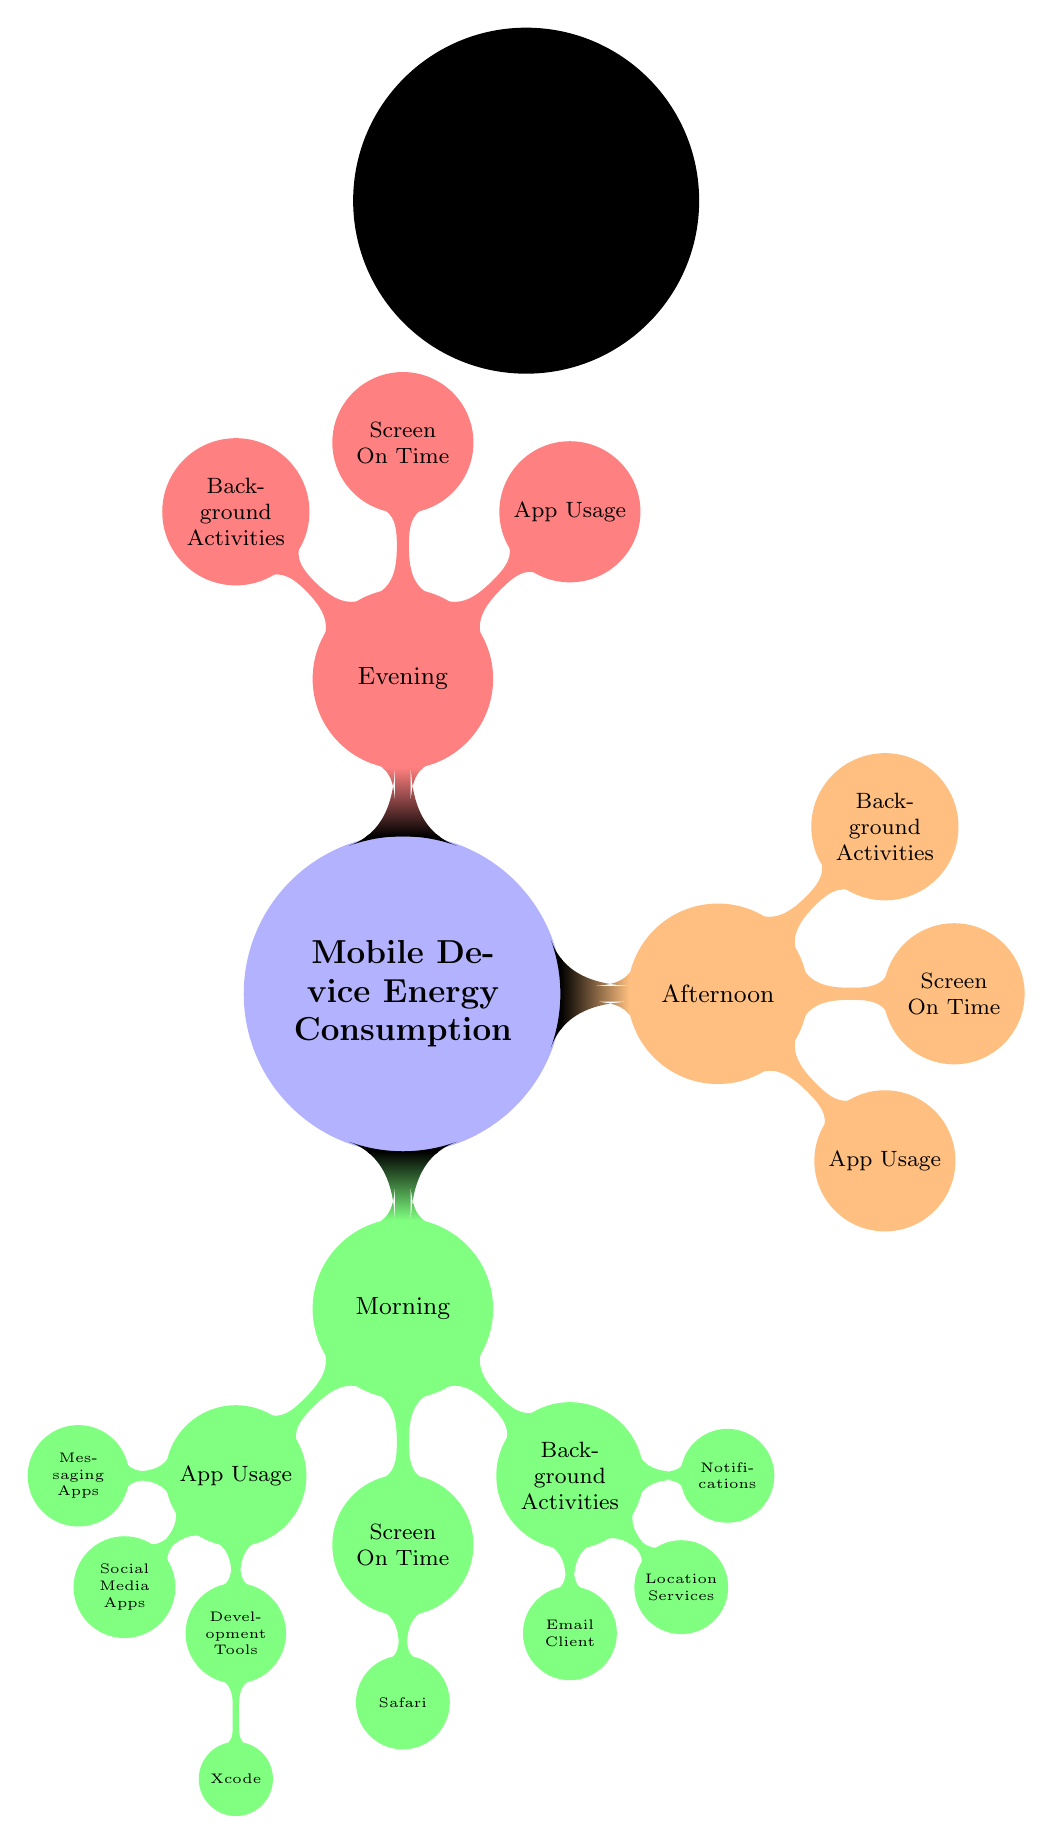What is the main topic of the diagram? The diagram is centered around the topic of mobile device energy consumption, specifically looking at how this consumption varies throughout a day. The title at the top clearly states this main focus.
Answer: Mobile Device Energy Consumption How many main time periods are represented? The diagram shows three main time periods: Morning, Afternoon, and Evening. These are the top-level nodes directly connected to the main topic.
Answer: Three Which specific app is mentioned under Morning for Development Tools? Under the "Development Tools" category in the Morning section, the specific app "Xcode" is mentioned as an example. This node is a child of the Development Tools node.
Answer: Xcode What type of activities are listed under the Morning section? In the Morning section, three types of activities are mentioned: App Usage, Screen On Time, and Background Activities. Each of these activities is crucial for understanding energy consumption patterns.
Answer: App Usage, Screen On Time, Background Activities How many child nodes are associated with Background Activities in the Morning section? In the Morning section, the "Background Activities" node has three child nodes: Email Client, Location Services, and Notifications. This total can be counted by examining the nodes connected to the Background Activities node.
Answer: Three Which time period has the category "Screen On Time"? The "Screen On Time" category appears in all three time periods: Morning, Afternoon, and Evening. Therefore, it is not limited to just one period but is relevant across the entire day.
Answer: Morning, Afternoon, Evening Which energy-consumption category appears in both Afternoon and Evening? The "App Usage" category is listed under both the Afternoon and Evening sections, indicating that this is a common factor in the mobile device's energy consumption during these time periods.
Answer: App Usage What specific activity is included under the Morning’s Screen On Time? The specific activity mentioned under the Morning section in "Screen On Time" is "Safari," which indicates that browsing uses energy during this period.
Answer: Safari 